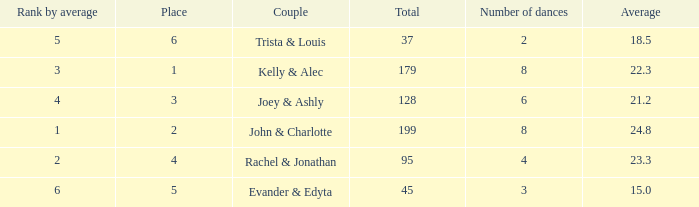What is the highest average that has 6 dances and a total of over 128? None. 